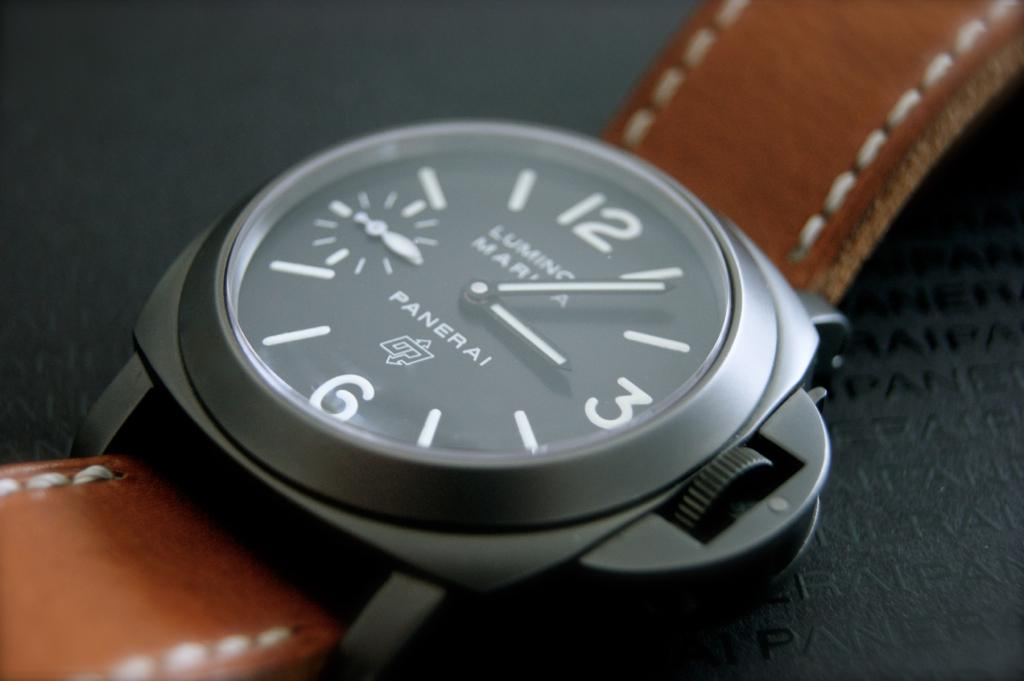Provide a one-sentence caption for the provided image. This image showcases a luxurious Panerai watch featuring a luminous black dial with stark white numerals, a prominent 12 and 6, and a distinctive brown leather strap, poised against a textured black background. 